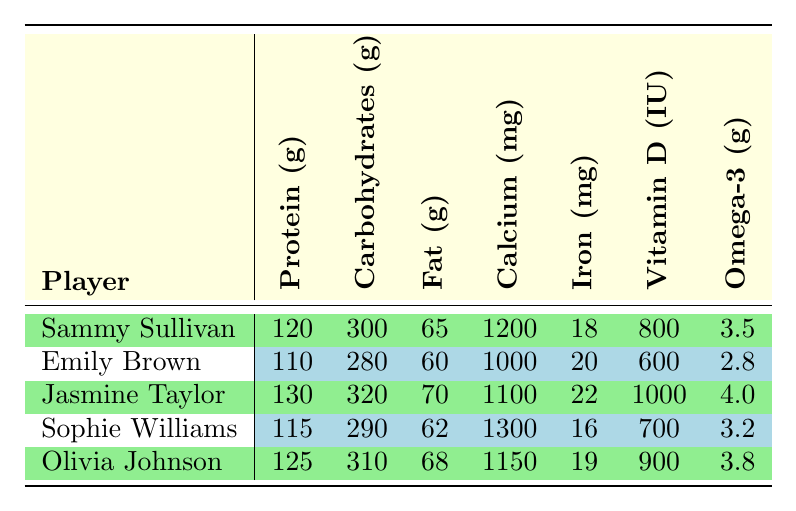What is the highest protein intake among the players? The table shows the protein intake values: Sammy Sullivan (120g), Emily Brown (110g), Jasmine Taylor (130g), Sophie Williams (115g), and Olivia Johnson (125g). The highest value is 130g from Jasmine Taylor.
Answer: 130g Which player has the lowest fat intake? The fat intake values are: Sammy Sullivan (65g), Emily Brown (60g), Jasmine Taylor (70g), Sophie Williams (62g), and Olivia Johnson (68g). The lowest value is 60g from Emily Brown.
Answer: 60g What is the total carbohydrate intake of all players? The carbohydrate intake values are: Sammy Sullivan (300g), Emily Brown (280g), Jasmine Taylor (320g), Sophie Williams (290g), and Olivia Johnson (310g). Adding these values gives (300 + 280 + 320 + 290 + 310) = 1500g.
Answer: 1500g Does Olivia Johnson have higher calcium intake than Jasmine Taylor? Olivia Johnson's calcium intake is 1150mg and Jasmine Taylor's is 1100mg. Since 1150mg is greater than 1100mg, Olivia Johnson does have a higher calcium intake.
Answer: Yes What is the average iron intake of the players? The iron intake values are: 18mg (Sammy Sullivan), 20mg (Emily Brown), 22mg (Jasmine Taylor), 16mg (Sophie Williams), and 19mg (Olivia Johnson). Summing these values results in (18 + 20 + 22 + 16 + 19) = 95mg. Dividing by the number of players (5) gives an average of 95/5 = 19mg.
Answer: 19mg Who has the highest Vitamin D intake? The Vitamin D intakes are: Sammy Sullivan (800 IU), Emily Brown (600 IU), Jasmine Taylor (1000 IU), Sophie Williams (700 IU), and Olivia Johnson (900 IU). The highest value is 1000 IU from Jasmine Taylor.
Answer: Jasmine Taylor What is the difference in Omega-3 intake between the player with the highest and lowest intake? The Omega-3 intakes are: Sammy Sullivan (3.5g), Emily Brown (2.8g), Jasmine Taylor (4.0g), Sophie Williams (3.2g), and Olivia Johnson (3.8g). The highest is 4.0g (Jasmine Taylor) and the lowest is 2.8g (Emily Brown). The difference is 4.0 - 2.8 = 1.2g.
Answer: 1.2g Which player has the most balanced macronutrient intake relative to the others? To identify the most balanced, consider the proportion of protein, carbohydrates, and fat for each player. Calculating the ratios and comparing shows that Olivia Johnson has a relatively balanced intake with a notable proportion of each macronutrient: 125g protein, 310g carbs, and 68g fat compared to others, making her intake balanced.
Answer: Olivia Johnson 